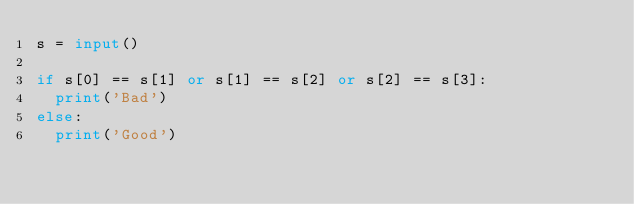Convert code to text. <code><loc_0><loc_0><loc_500><loc_500><_Python_>s = input()

if s[0] == s[1] or s[1] == s[2] or s[2] == s[3]:
  print('Bad')
else:
  print('Good')
</code> 